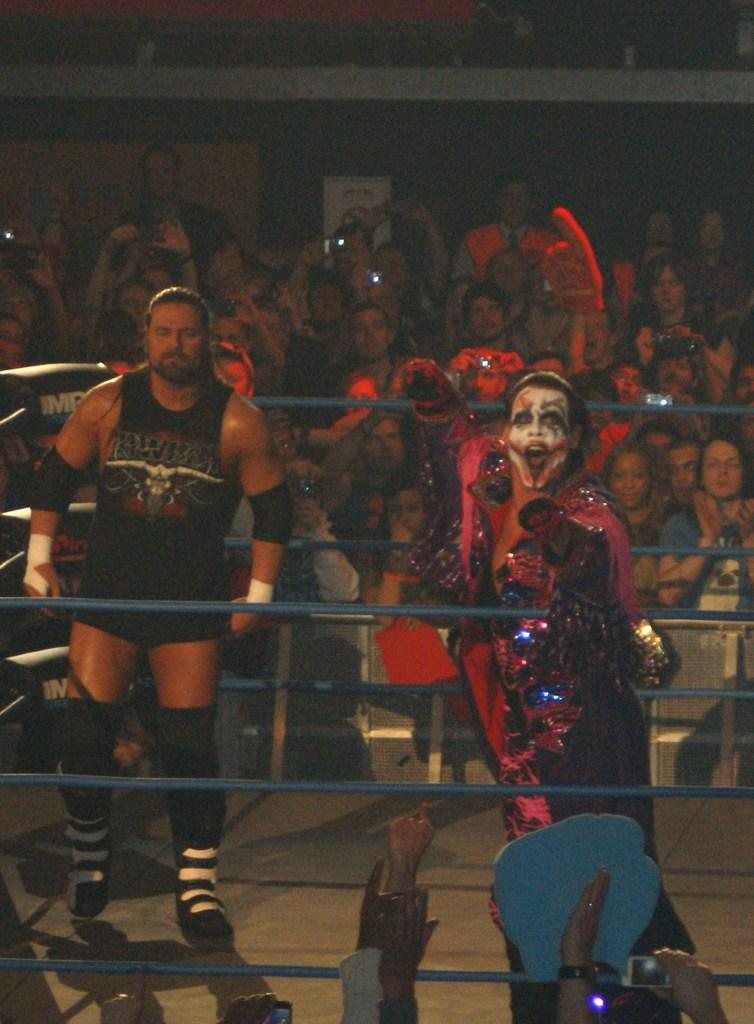What is a What type of event is taking place in the image? There is a competition being held in the image. Can you describe the main subjects in the image? There are two people at the center of the hall. What else can be observed about the people in the image? There are many other people around them. How many jellyfish are swimming in the background of the image? There are no jellyfish present in the image; it features a competition being held in a hall. What color is the dress worn by the person on the left? There is no specific mention of a dress or a person's clothing in the image, so we cannot determine the color of any dress. 